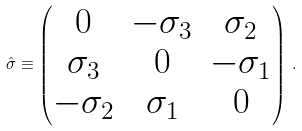<formula> <loc_0><loc_0><loc_500><loc_500>\hat { \sigma } \equiv \begin{pmatrix} 0 & - \sigma _ { 3 } & \sigma _ { 2 } \\ \sigma _ { 3 } & 0 & - \sigma _ { 1 } \\ - \sigma _ { 2 } & \sigma _ { 1 } & 0 \end{pmatrix} \, .</formula> 